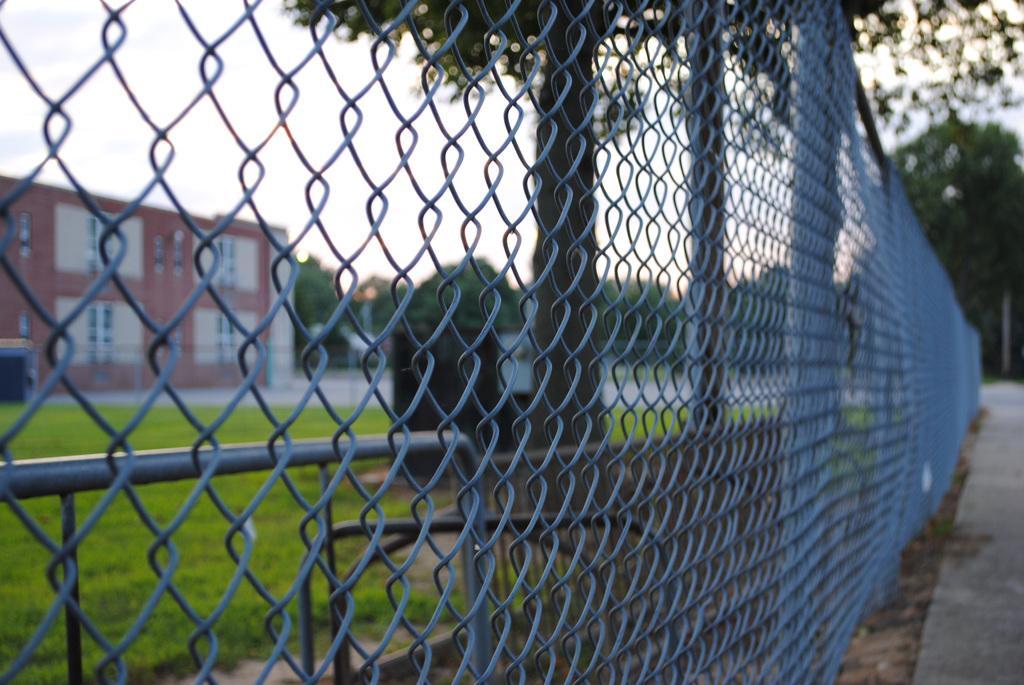Could you give a brief overview of what you see in this image? In this picture I can see a building on the left side and I can see metal fence and few trees in the back and I can see cloudy sky and grass on the ground. 